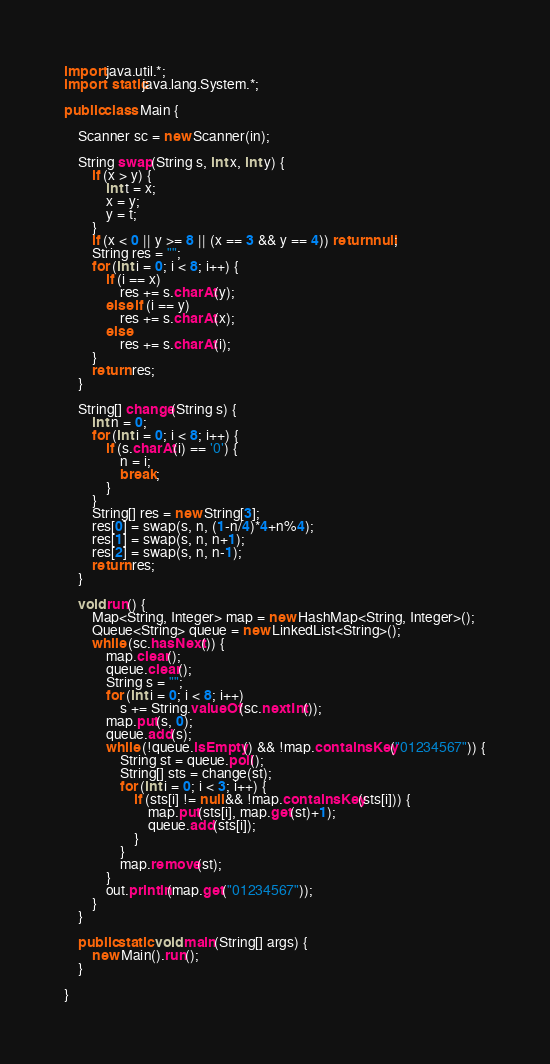<code> <loc_0><loc_0><loc_500><loc_500><_Java_>import java.util.*;
import static java.lang.System.*;

public class Main {

	Scanner sc = new Scanner(in);
	
	String swap(String s, int x, int y) {
		if (x > y) {
			int t = x;
			x = y; 
			y = t;
		}
		if (x < 0 || y >= 8 || (x == 3 && y == 4)) return null;
		String res = "";
		for (int i = 0; i < 8; i++) {
			if (i == x)
				res += s.charAt(y);
			else if (i == y)
				res += s.charAt(x);
			else
				res += s.charAt(i);
		}
		return res;
	}
	
	String[] change(String s) {
		int n = 0;
		for (int i = 0; i < 8; i++) {
			if (s.charAt(i) == '0') {
				n = i;
				break;
			}
		}
		String[] res = new String[3];
		res[0] = swap(s, n, (1-n/4)*4+n%4);
		res[1] = swap(s, n, n+1);
		res[2] = swap(s, n, n-1);
		return res;
	}
	
	void run() {
		Map<String, Integer> map = new HashMap<String, Integer>();
		Queue<String> queue = new LinkedList<String>();
		while (sc.hasNext()) {
			map.clear();
			queue.clear();
			String s = "";
			for (int i = 0; i < 8; i++)
				s += String.valueOf(sc.nextInt());
			map.put(s, 0);
			queue.add(s);
			while (!queue.isEmpty() && !map.containsKey("01234567")) {
				String st = queue.poll();
				String[] sts = change(st);
				for (int i = 0; i < 3; i++) {
					if (sts[i] != null && !map.containsKey(sts[i])) {
						map.put(sts[i], map.get(st)+1);
						queue.add(sts[i]);
					}
				}
				map.remove(st);
			}
			out.println(map.get("01234567"));
		}
	}
	
	public static void main(String[] args) {
		new Main().run();
	}

}</code> 